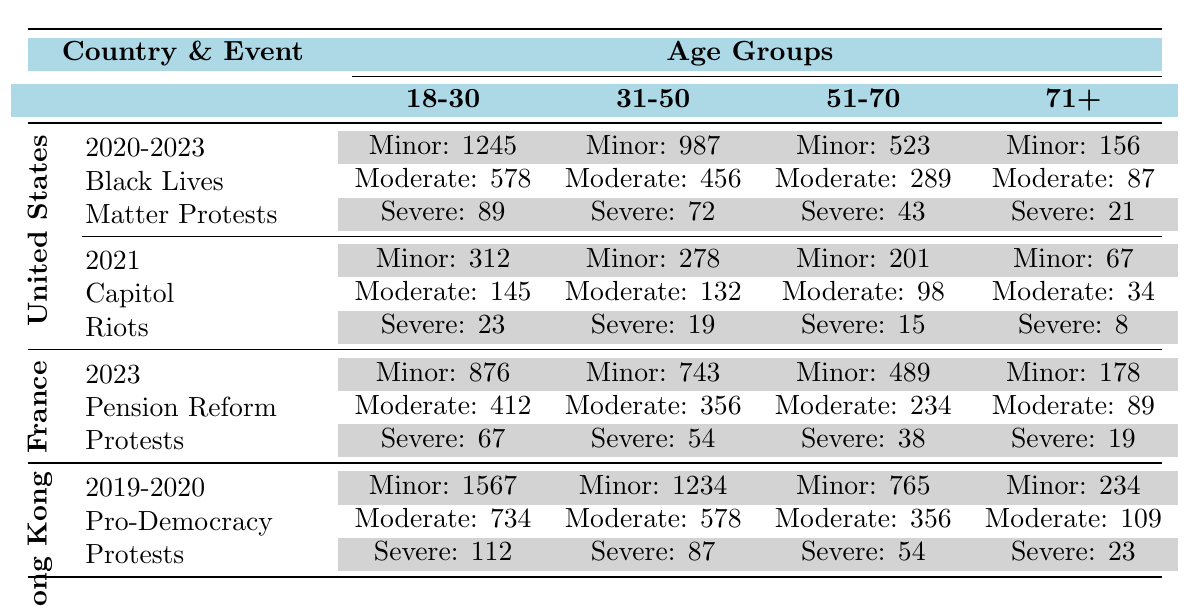What is the total number of minor injuries in the United States during the 2020-2023 Black Lives Matter Protests? To find the total number of minor injuries, we add the values for the age groups: 1245 (18-30) + 987 (31-50) + 523 (51-70) + 156 (71+) = 2911.
Answer: 2911 What is the highest number of severe injuries reported in the table, and in which event did it occur? The highest number of severe injuries is 112, which occurred during the Hong Kong 2019-2020 Pro-Democracy Protests.
Answer: 112, Hong Kong Protests How many moderate injuries were reported for the age group 31-50 during the 2021 Capitol Riots? The number of moderate injuries for the age group 31-50 during the Capitol Riots is directly stated in the table as 132.
Answer: 132 What is the total number of severe injuries from all events for the age group 71+? We add the severe injuries for the age group 71+: 21 (2020-2023 BLM) + 8 (2021 Capitol Riots) + 19 (2023 Pension Reform) + 23 (2019-2020 Protests) = 71.
Answer: 71 How do the minor injuries in the Hong Kong protests compare to those in the U.S. Black Lives Matter protests for the 18-30 age group? In the Hong Kong protests, the minor injuries for 18-30 age group are 1567, while for the U.S. BLM protests, they are 1245. Comparing these values shows that Hong Kong had 322 more minor injuries.
Answer: 322 more in Hong Kong Is the total number of moderate injuries higher in the France Pension Reform Protests or the Hong Kong Protests? We need to find and compare total moderate injuries: France = 412 + 356 + 234 + 89 = 1091; Hong Kong = 734 + 578 + 356 + 109 = 1977. Since 1977 > 1091, Hong Kong has higher injuries.
Answer: Yes, higher in Hong Kong What is the average number of severe injuries for the age group 51-70 across all events? We first find the values across events: U.S. BLM = 43, U.S. Capitol = 15, France = 38, Hong Kong = 54. Then we calculate the average: (43 + 15 + 38 + 54) / 4 = 37.5.
Answer: 37.5 Which event had the least number of minor injuries in the age group 71+? Looking at the table, the minor injuries for age group 71+ across events are: U.S. BLM = 156, U.S. Capitol = 67, France = 178, Hong Kong = 234. The least is 67 from the U.S. Capitol Riots.
Answer: U.S. Capitol Riots How many more moderate injuries were there in the France protests compared to the U.S. Capitol Riots for the 31-50 age group? Moderate injuries in France for 31-50 = 356, and in the U.S. Capitol Riots = 132. The difference is 356 - 132 = 224 more in France.
Answer: 224 more in France 